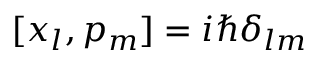Convert formula to latex. <formula><loc_0><loc_0><loc_500><loc_500>[ x _ { l } , p _ { m } ] = i \hbar { \delta } _ { l m }</formula> 